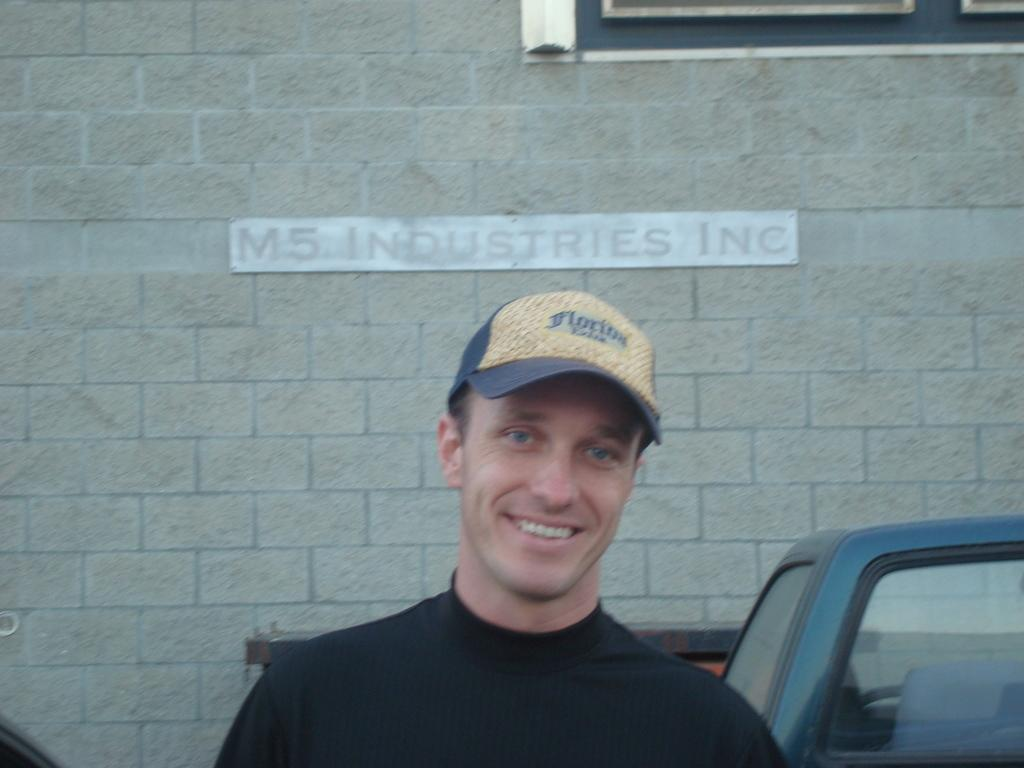What is the person in the image doing? The person is standing in the image. What is the person wearing on their head? The person is wearing a cap. What can be seen in the image besides the person? There is a car and a building in the image. What material is the building made of? The building is made up of bricks. Can you see the person's toe in the image? There is no indication of the person's toe in the image. What type of kite is the person holding in the image? There is no kite present in the image. 